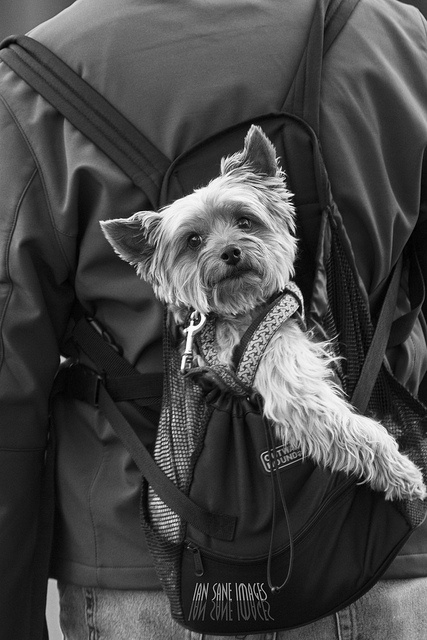Describe the objects in this image and their specific colors. I can see backpack in gray, black, darkgray, and lightgray tones and dog in gray, darkgray, lightgray, and black tones in this image. 